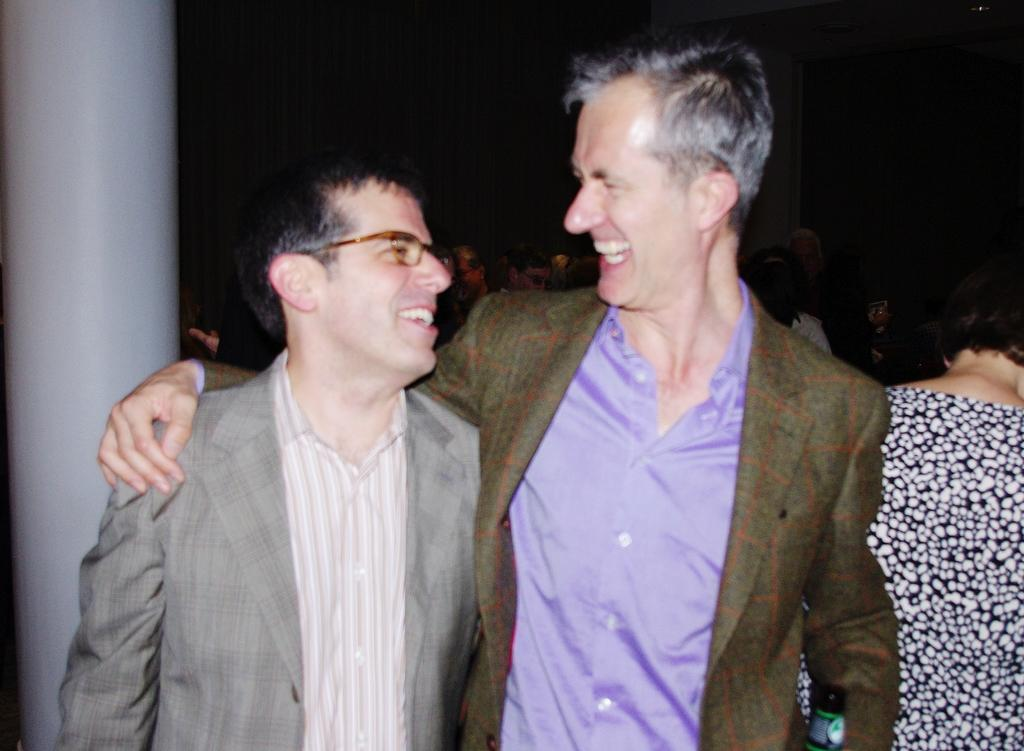What are the two individuals in the image wearing? One person is wearing a blazer, and the other person is wearing spectacles and a blazer. Can you describe the people behind the two individuals? There are people visible behind the two individuals, but their clothing or features cannot be determined from the provided facts. What is located on the left side of the image? There is a pillar on the left side of the image. Is there a pocket on the stick held by the person in the image? There is no stick or pocket present in the image. 